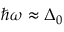<formula> <loc_0><loc_0><loc_500><loc_500>\hbar { \omega } \approx \Delta _ { 0 }</formula> 